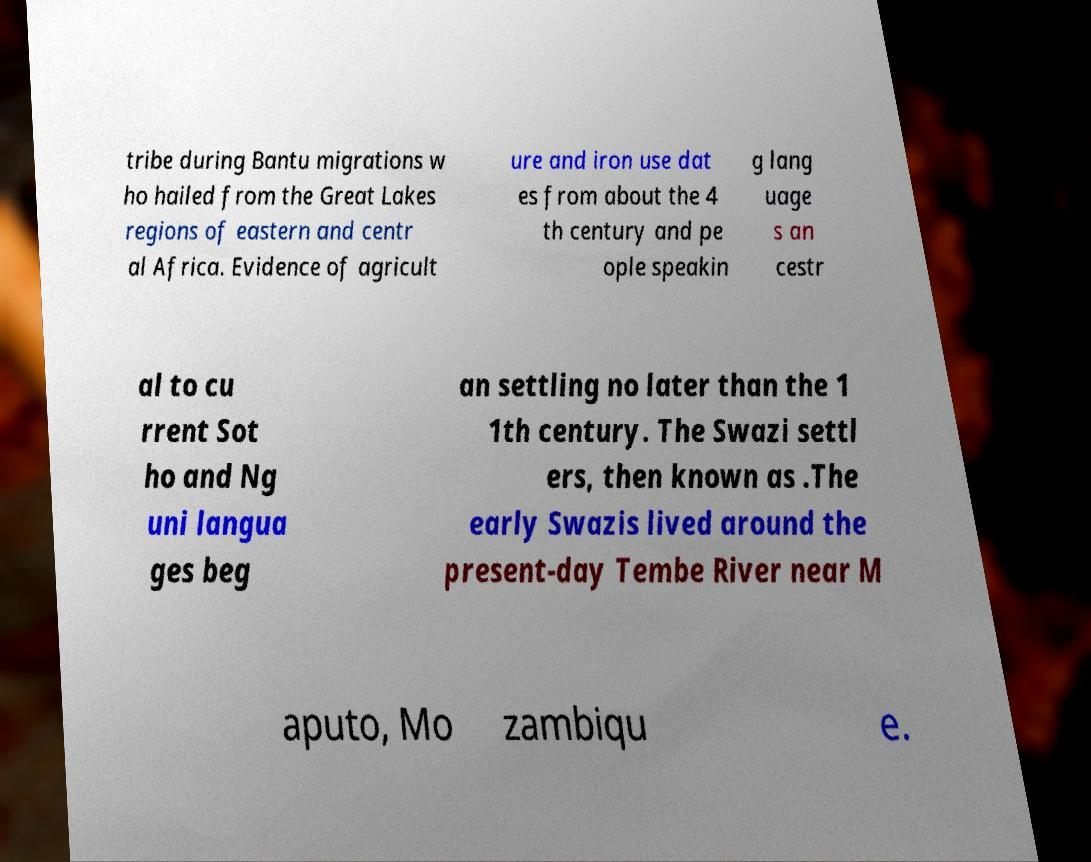There's text embedded in this image that I need extracted. Can you transcribe it verbatim? tribe during Bantu migrations w ho hailed from the Great Lakes regions of eastern and centr al Africa. Evidence of agricult ure and iron use dat es from about the 4 th century and pe ople speakin g lang uage s an cestr al to cu rrent Sot ho and Ng uni langua ges beg an settling no later than the 1 1th century. The Swazi settl ers, then known as .The early Swazis lived around the present-day Tembe River near M aputo, Mo zambiqu e. 